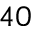Convert formula to latex. <formula><loc_0><loc_0><loc_500><loc_500>^ { 4 0 }</formula> 